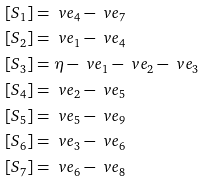Convert formula to latex. <formula><loc_0><loc_0><loc_500><loc_500>[ S _ { 1 } ] & = \ v e _ { 4 } - \ v e _ { 7 } \\ [ S _ { 2 } ] & = \ v e _ { 1 } - \ v e _ { 4 } \\ [ S _ { 3 } ] & = \eta - \ v e _ { 1 } - \ v e _ { 2 } - \ v e _ { 3 } \\ [ S _ { 4 } ] & = \ v e _ { 2 } - \ v e _ { 5 } \\ [ S _ { 5 } ] & = \ v e _ { 5 } - \ v e _ { 9 } \\ [ S _ { 6 } ] & = \ v e _ { 3 } - \ v e _ { 6 } \\ [ S _ { 7 } ] & = \ v e _ { 6 } - \ v e _ { 8 }</formula> 